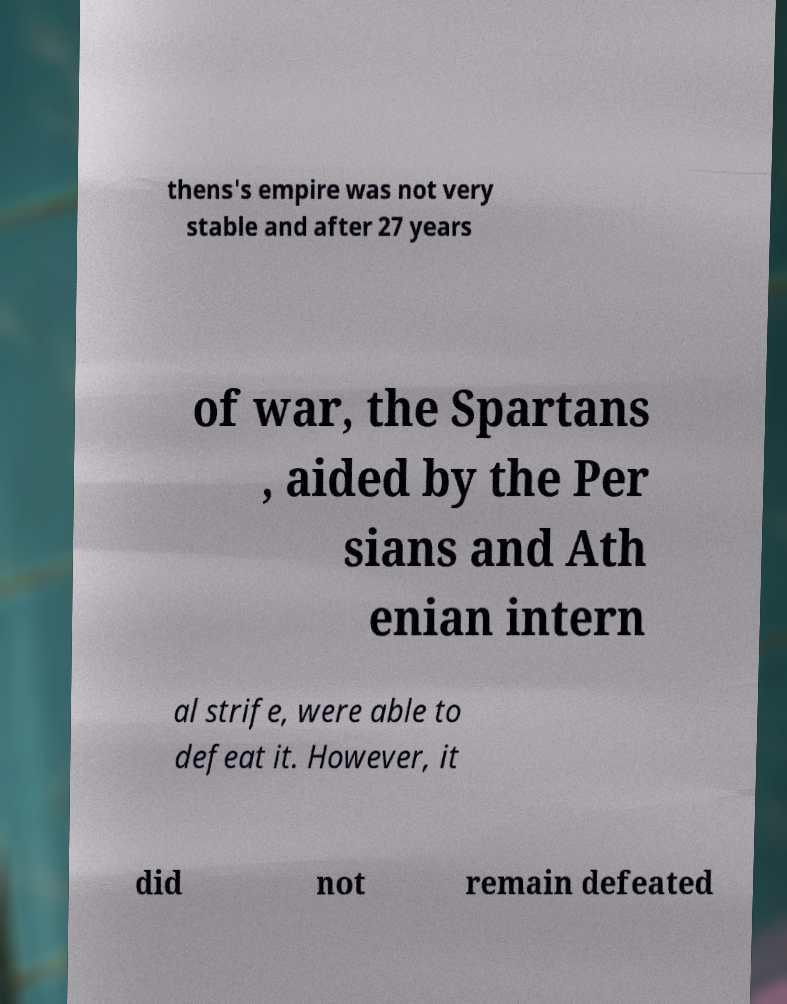Could you extract and type out the text from this image? thens's empire was not very stable and after 27 years of war, the Spartans , aided by the Per sians and Ath enian intern al strife, were able to defeat it. However, it did not remain defeated 